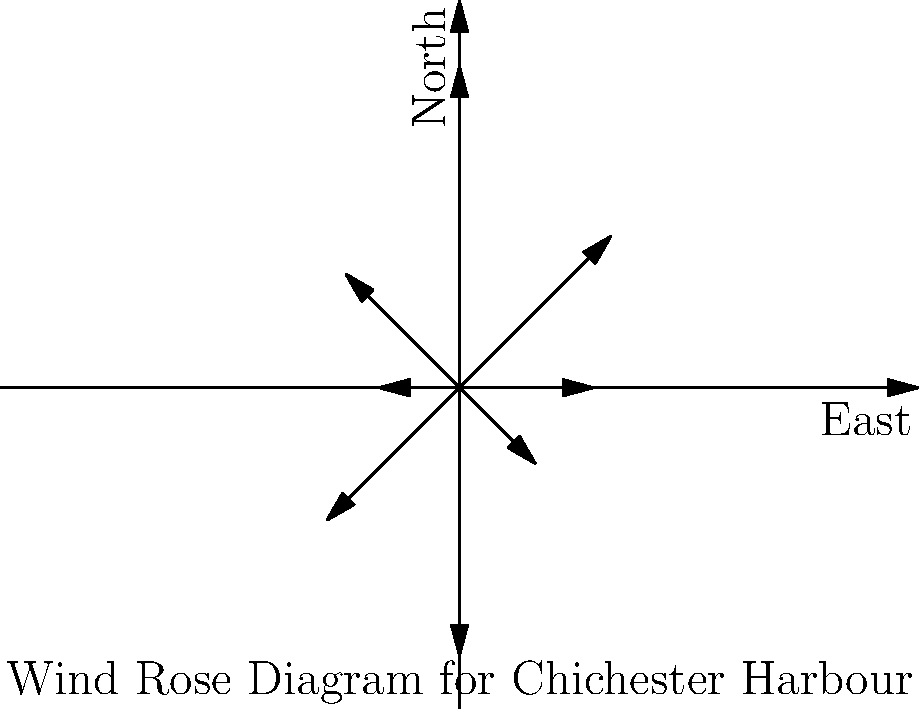Based on the wind rose diagram for Chichester Harbour, which direction has the highest wind speed, and what is that speed in knots? To answer this question, we need to analyze the wind rose diagram:

1. The diagram shows wind directions and speeds using arrows.
2. The length of each arrow represents the wind speed.
3. The direction of the arrow indicates the direction from which the wind is blowing.

Let's examine each direction:
- 0° (East): 5 knots
- 45° (Northeast): 8 knots
- 90° (North): 12 knots
- 135° (Northwest): 6 knots
- 180° (West): 3 knots
- 225° (Southwest): 7 knots
- 270° (South): 10 knots
- 315° (Southeast): 4 knots

The longest arrow, representing the highest wind speed, points towards the south (270°). This arrow corresponds to a wind speed of 12 knots.

Therefore, the direction with the highest wind speed is from the north (90°), with a speed of 12 knots.
Answer: North, 12 knots 